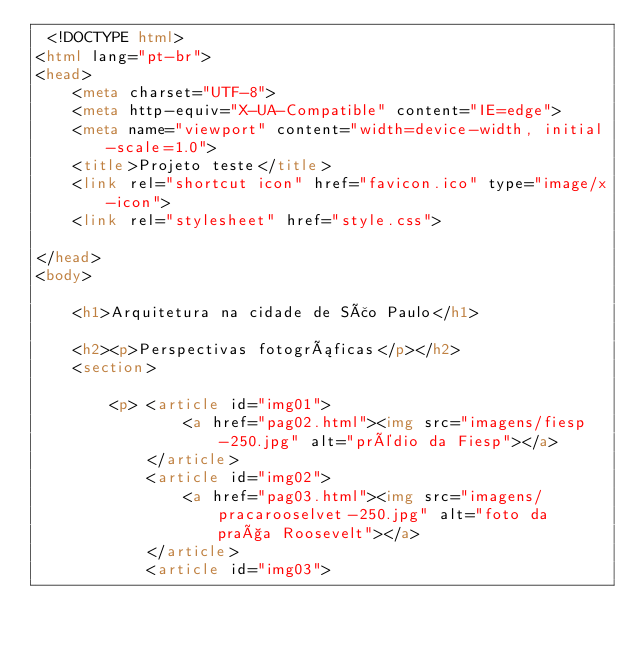<code> <loc_0><loc_0><loc_500><loc_500><_HTML_> <!DOCTYPE html>
<html lang="pt-br">
<head>
    <meta charset="UTF-8">
    <meta http-equiv="X-UA-Compatible" content="IE=edge">
    <meta name="viewport" content="width=device-width, initial-scale=1.0">
    <title>Projeto teste</title>
    <link rel="shortcut icon" href="favicon.ico" type="image/x-icon">
    <link rel="stylesheet" href="style.css">
    
</head>
<body>
    
    <h1>Arquitetura na cidade de São Paulo</h1>

    <h2><p>Perspectivas fotográficas</p></h2>
    <section>
        
        <p> <article id="img01">
                <a href="pag02.html"><img src="imagens/fiesp-250.jpg" alt="prédio da Fiesp"></a>
            </article>
            <article id="img02">
                <a href="pag03.html"><img src="imagens/pracarooselvet-250.jpg" alt="foto da praça Roosevelt"></a>
            </article>
            <article id="img03"></code> 